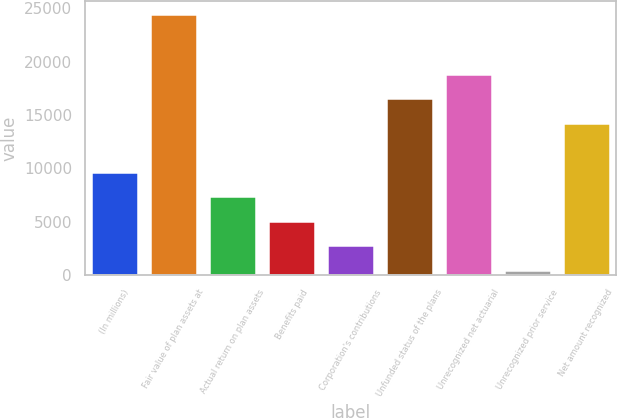Convert chart to OTSL. <chart><loc_0><loc_0><loc_500><loc_500><bar_chart><fcel>(In millions)<fcel>Fair value of plan assets at<fcel>Actual return on plan assets<fcel>Benefits paid<fcel>Corporation's contributions<fcel>Unfunded status of the plans<fcel>Unrecognized net actuarial<fcel>Unrecognized prior service<fcel>Net amount recognized<nl><fcel>9668<fcel>24433<fcel>7374<fcel>5080<fcel>2786<fcel>16550<fcel>18844<fcel>492<fcel>14256<nl></chart> 